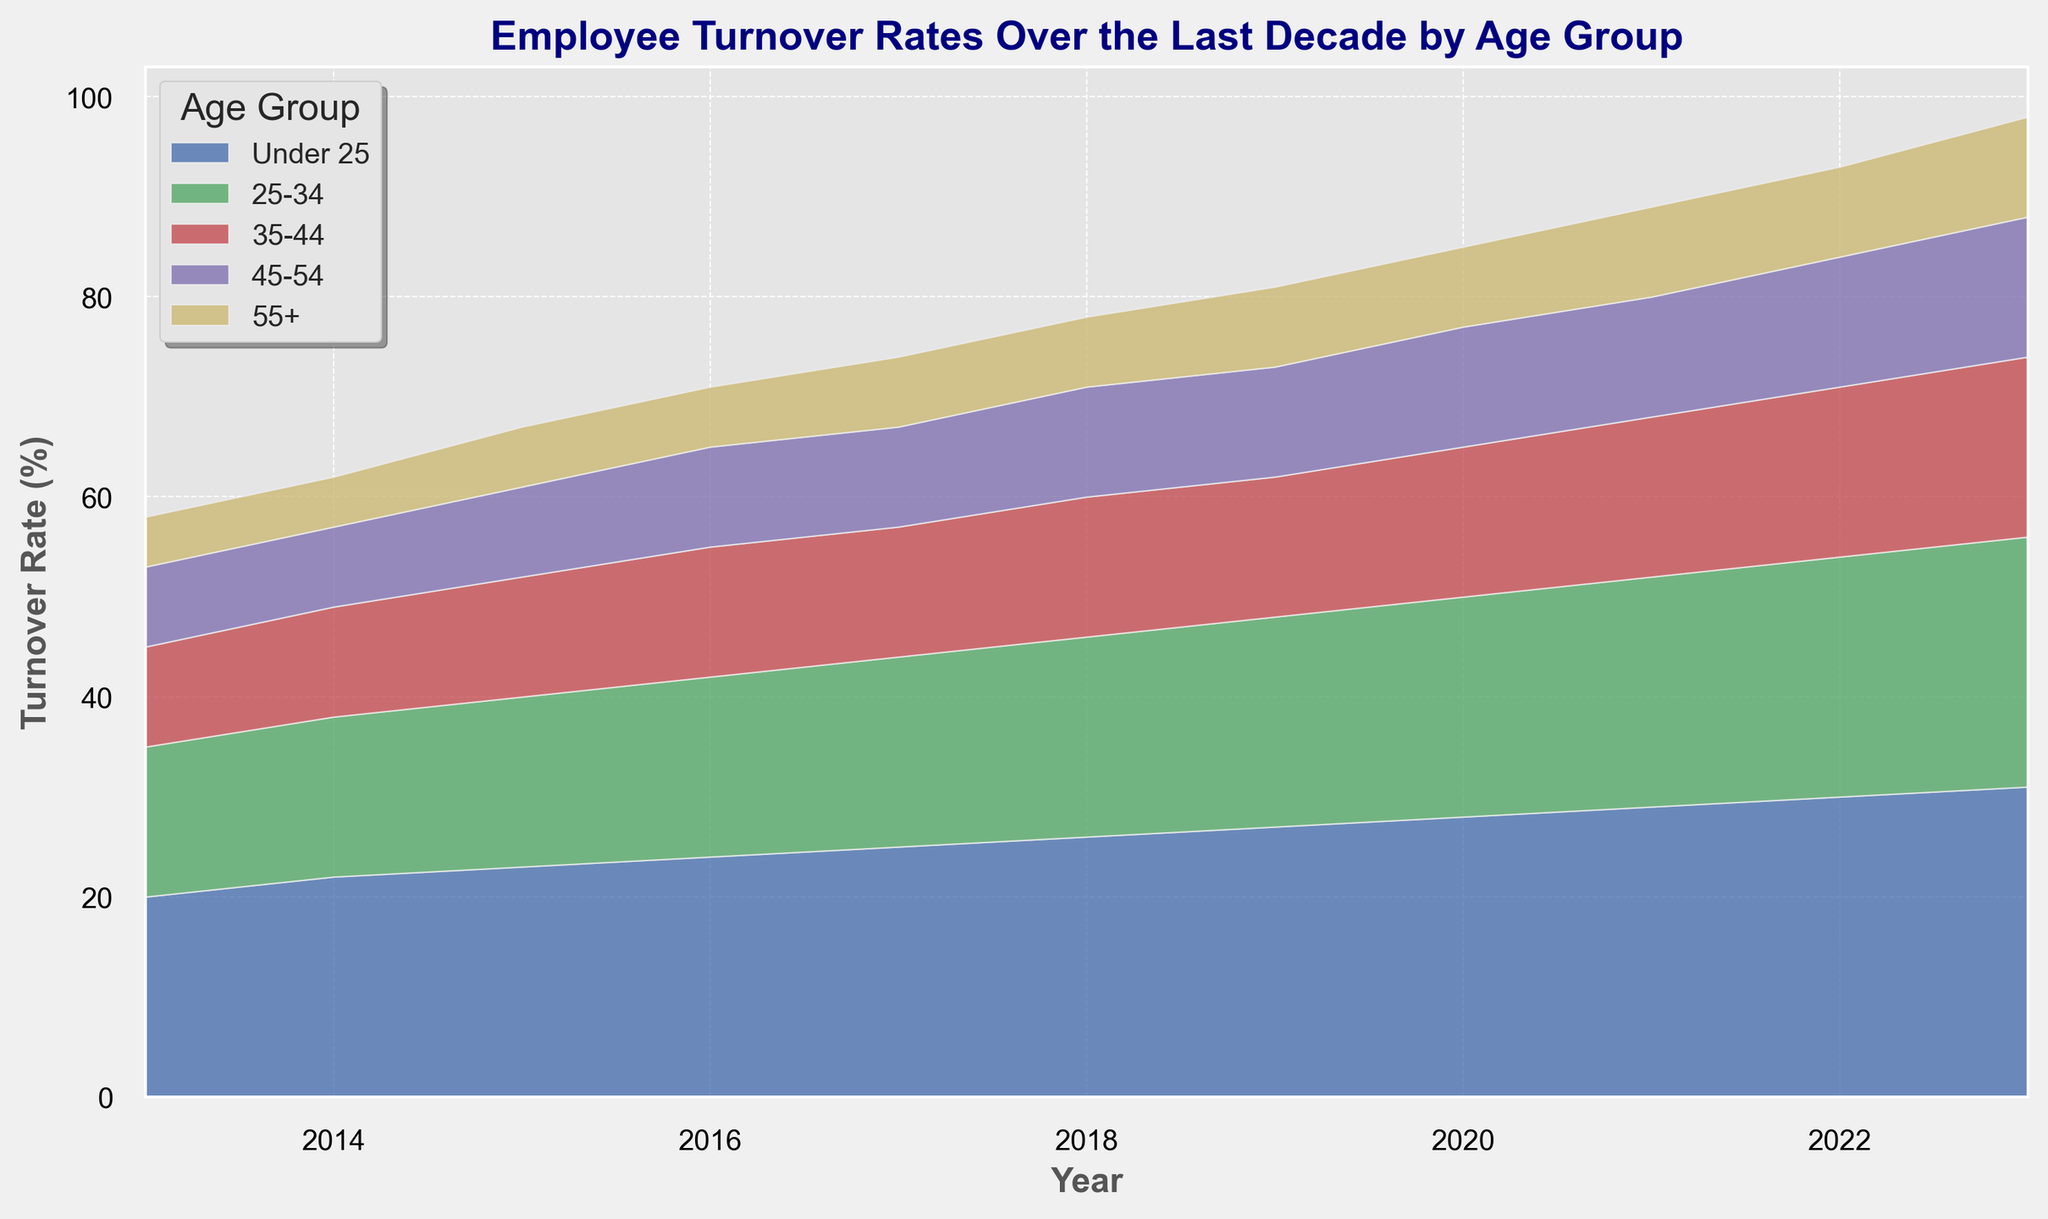What is the general trend in the turnover rates for employees under 25 over the last decade? The turnover rate for employees under 25 generally increases each year from 20% in 2013 to 31% in 2023.
Answer: An increasing trend Which age group has the highest turnover rate in 2023? By examining the height of each area, the age group "Under 25" has the highest turnover rate at 31% in 2023.
Answer: Under 25 How has the turnover rate changed for the age group 35-44 from 2013 to 2023? The turnover rate for the age group 35-44 increased from 10% in 2013 to 18% in 2023.
Answer: It increased Compare the turnover rates of the age groups 45-54 and 55+ in 2022. In 2022, the turnover rates are 13% for the age group 45-54 and 9% for age group 55+. 13% is greater than 9%.
Answer: The age group 45-54 has a higher turnover rate What is the sum of turnover rates for all age groups in 2015? Sum the turnover rates for 2015: 23% (Under 25) + 17% (25-34) + 12% (35-44) + 9% (45-54) + 6% (55+) = 67%.
Answer: 67% Which age group shows the most stable turnover rate over the decade? By looking at the visual spread and fluctuation, the age group 55+ remains relatively stable, starting at 5% in 2013 and ending at 10% in 2023 with small yearly increments.
Answer: 55+ Compare the rate of increase in turnover rates for the age groups 25-34 and 45-54 from 2013 to 2023. The turnover rate for the age group 25-34 goes from 15% (2013) to 25% (2023), an increase of 10%. The rate for age group 45-54 goes from 8% (2013) to 14% (2023), an increase of 6%. Therefore, the 25-34 group has a higher rate of increase.
Answer: Age group 25-34 What is the difference in turnover rates for the age group 25-34 between 2016 and 2020? The turnover rate for the age group 25-34 is 18% in 2016 and 22% in 2020, so the difference is 22% - 18% = 4%.
Answer: 4% How many years did it take for the turnover rate of the age group 55+ to double since 2013? The turnover rate for the age group 55+ was 5% in 2013 and doubled to 10% by 2023. It took 2023 - 2013 = 10 years.
Answer: 10 years 